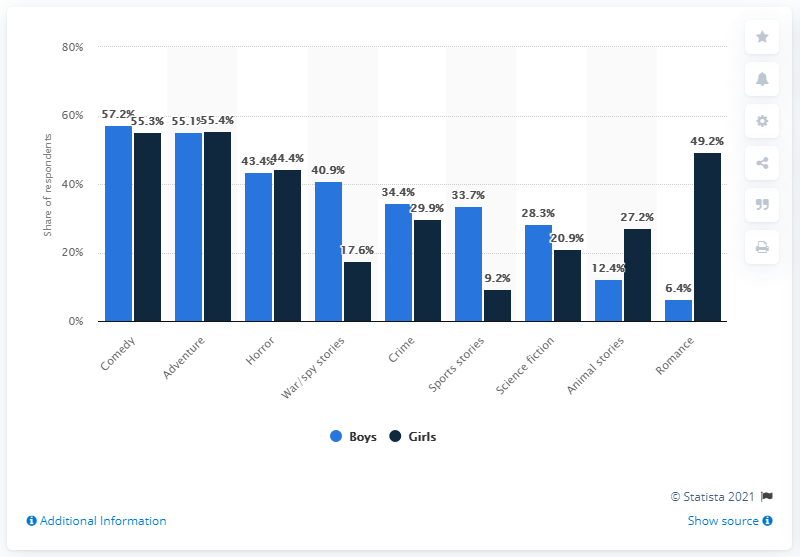Specify some key components in this picture. According to the text, girls were more likely to enjoy reading romance and animal stories than boys. 